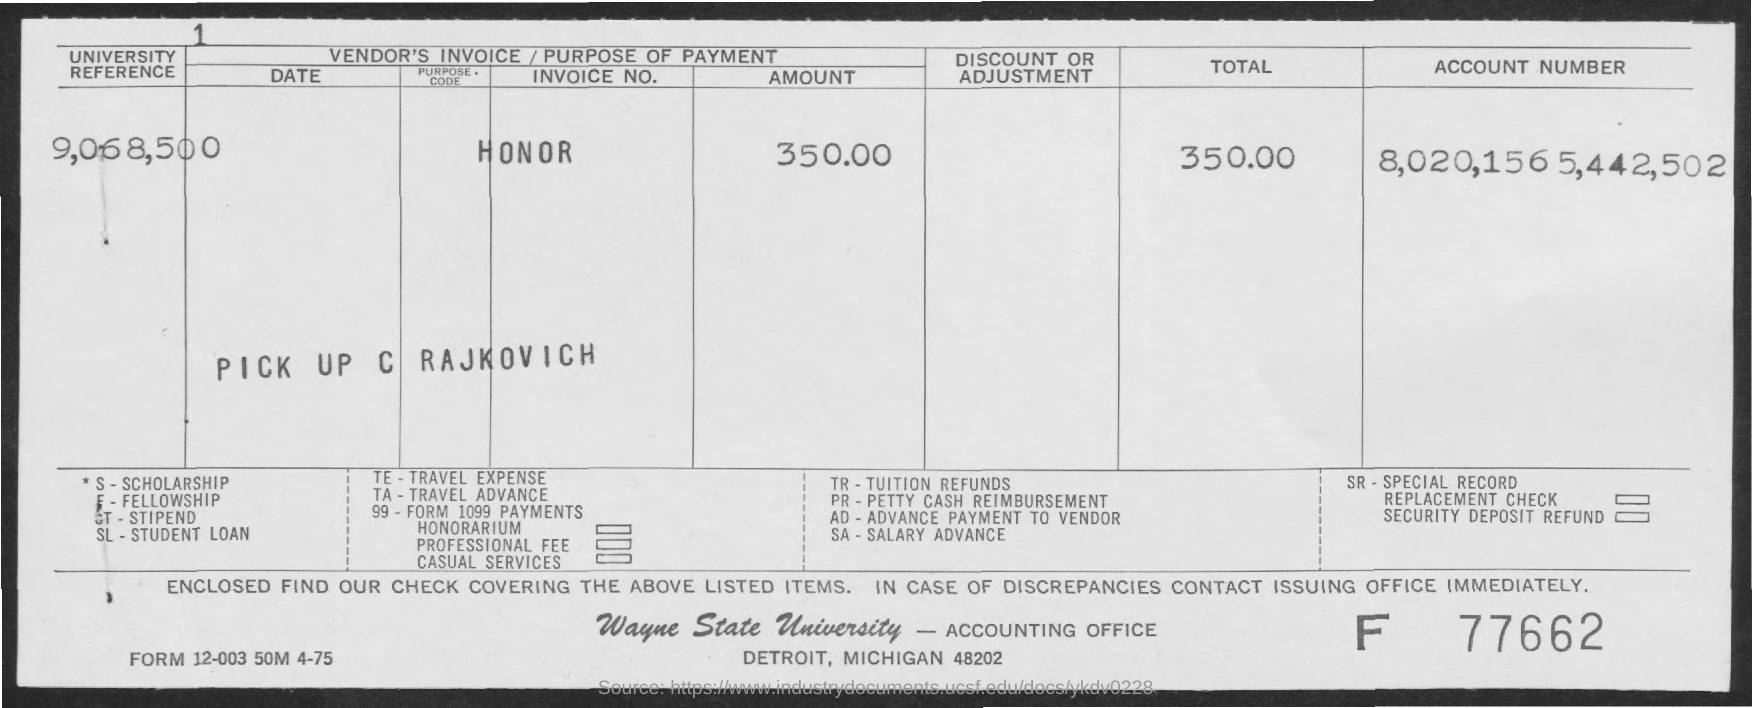Point out several critical features in this image. The fullform for TE is Travel Expense. SA stands for salary advance. The acronym 'TA' stands for 'Travel Advance.'  The total amount is 350.00. SL stands for student loan, which is a type of loan provided to students to help cover the cost of their education. 